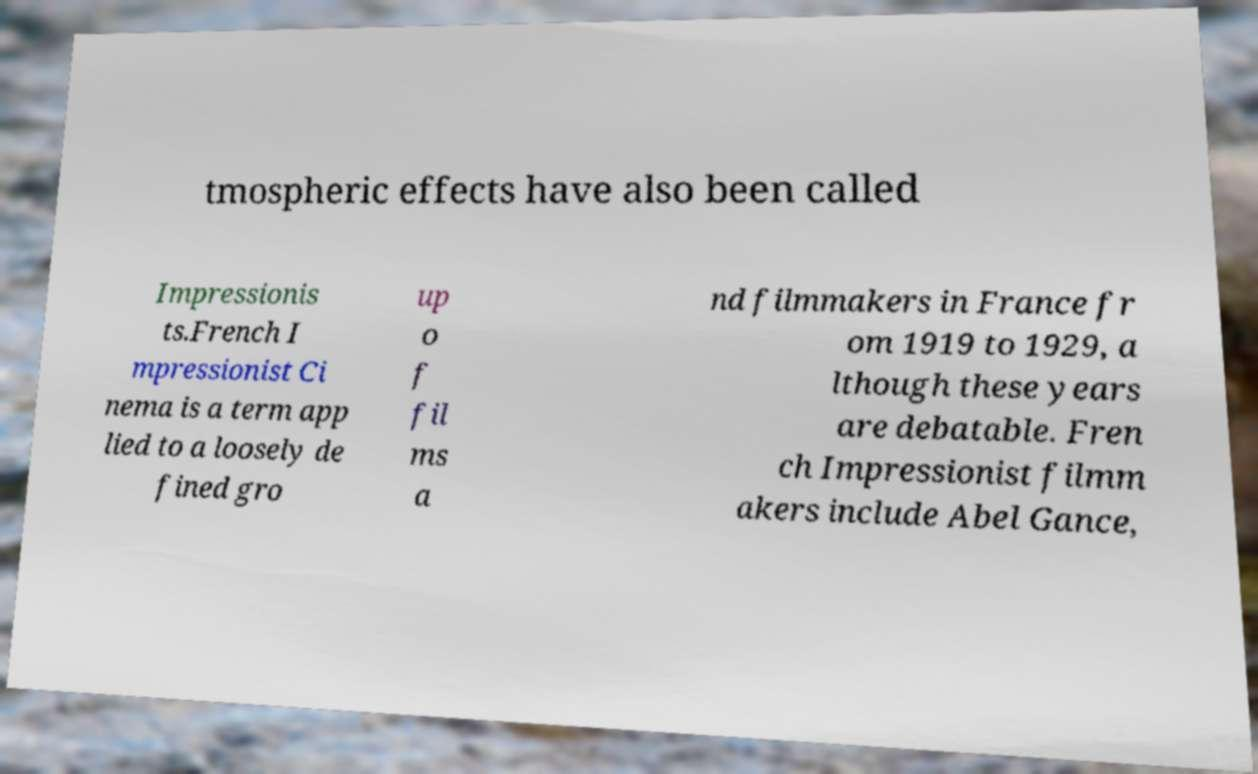For documentation purposes, I need the text within this image transcribed. Could you provide that? tmospheric effects have also been called Impressionis ts.French I mpressionist Ci nema is a term app lied to a loosely de fined gro up o f fil ms a nd filmmakers in France fr om 1919 to 1929, a lthough these years are debatable. Fren ch Impressionist filmm akers include Abel Gance, 